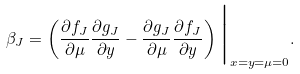<formula> <loc_0><loc_0><loc_500><loc_500>\beta _ { J } = \left ( \frac { \partial f _ { J } } { \partial \mu } \frac { \partial g _ { J } } { \partial y } - \frac { \partial g _ { J } } { \partial \mu } \frac { \partial f _ { J } } { \partial y } \right ) \Big | _ { x = y = \mu = 0 } .</formula> 